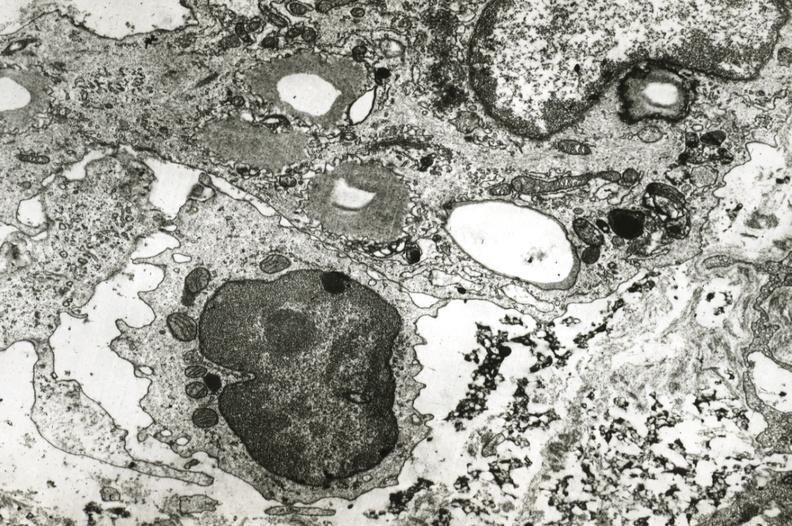where is this?
Answer the question using a single word or phrase. Vasculature 